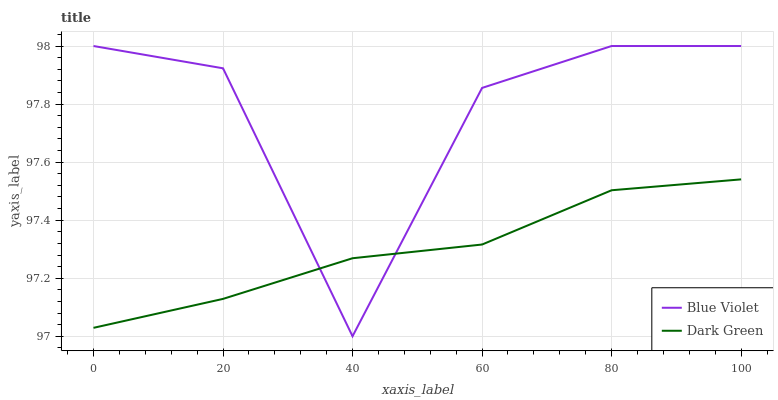Does Dark Green have the minimum area under the curve?
Answer yes or no. Yes. Does Blue Violet have the maximum area under the curve?
Answer yes or no. Yes. Does Dark Green have the maximum area under the curve?
Answer yes or no. No. Is Dark Green the smoothest?
Answer yes or no. Yes. Is Blue Violet the roughest?
Answer yes or no. Yes. Is Dark Green the roughest?
Answer yes or no. No. Does Blue Violet have the lowest value?
Answer yes or no. Yes. Does Dark Green have the lowest value?
Answer yes or no. No. Does Blue Violet have the highest value?
Answer yes or no. Yes. Does Dark Green have the highest value?
Answer yes or no. No. Does Dark Green intersect Blue Violet?
Answer yes or no. Yes. Is Dark Green less than Blue Violet?
Answer yes or no. No. Is Dark Green greater than Blue Violet?
Answer yes or no. No. 